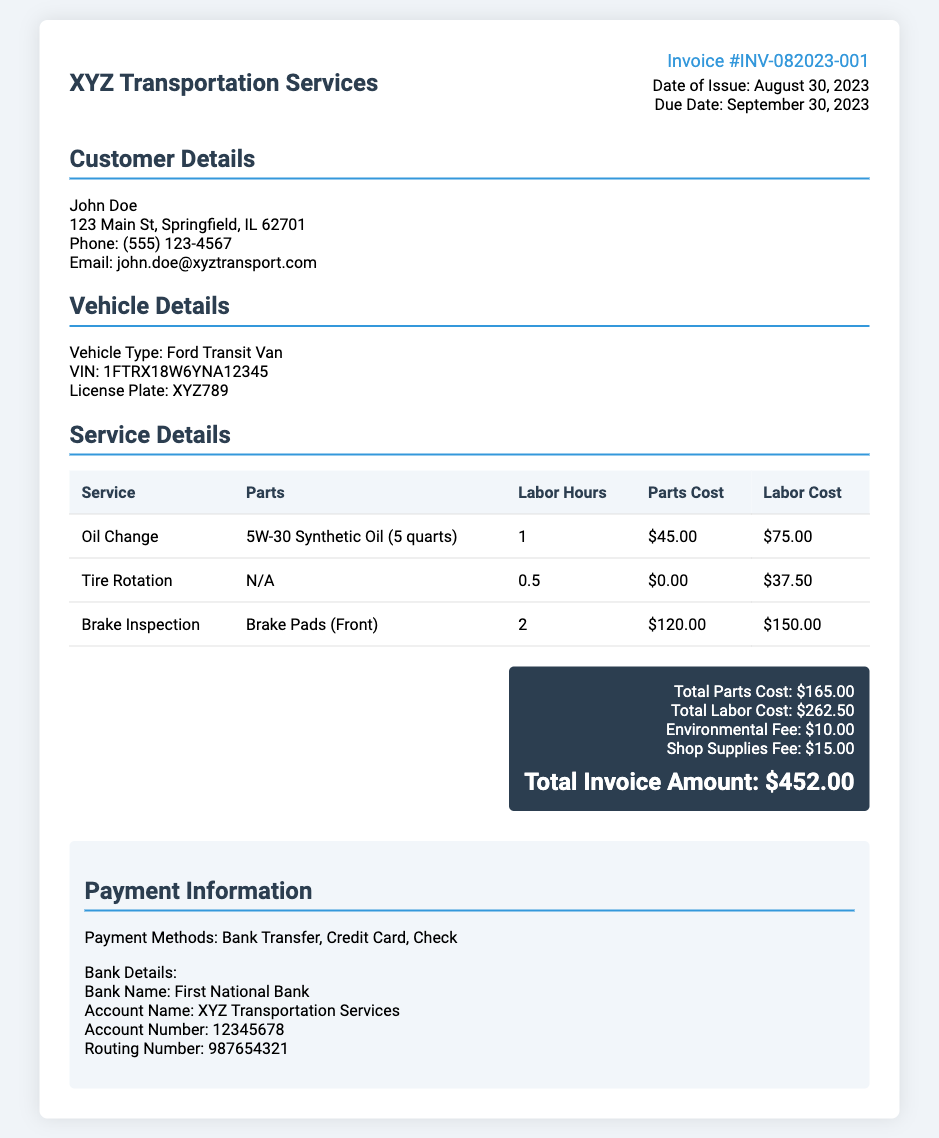what is the invoice number? The invoice number is clearly stated in the document for easy reference, which is INV-082023-001.
Answer: INV-082023-001 what is the date of issue? The date the invoice was issued is provided, which is August 30, 2023.
Answer: August 30, 2023 who is the customer? The customer details are included, identifying the individual as John Doe.
Answer: John Doe what is the total invoice amount? The total invoice amount is calculated from the parts, labor, and additional fees listed, which comes to $452.00.
Answer: $452.00 how much was charged for brake inspection labor? The labor cost for the brake inspection is specified in the service details, totaling $150.00.
Answer: $150.00 what parts were used for the oil change? The parts used for the oil change are detailed in the table, which lists 5W-30 Synthetic Oil (5 quarts).
Answer: 5W-30 Synthetic Oil (5 quarts) what is the due date for payment? The due date is specified in the document, which is September 30, 2023.
Answer: September 30, 2023 what are the payment methods listed? The document provides different options for payment, which are Bank Transfer, Credit Card, and Check.
Answer: Bank Transfer, Credit Card, Check what is the environmental fee? The environmental fee is noted in the total section of the invoice as $10.00.
Answer: $10.00 how many labor hours were spent on tire rotation? The labor hours for tire rotation are specified in the service table as 0.5 hours.
Answer: 0.5 